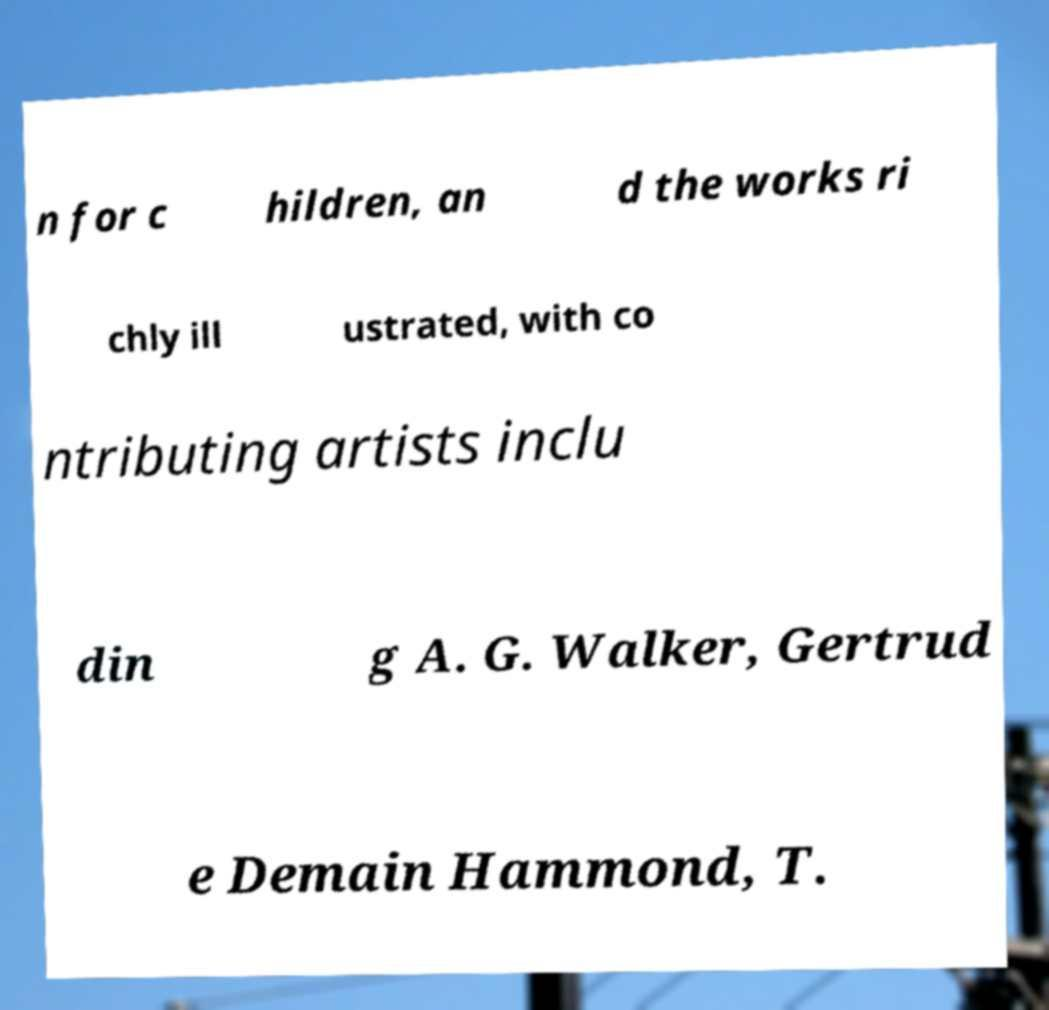Please read and relay the text visible in this image. What does it say? n for c hildren, an d the works ri chly ill ustrated, with co ntributing artists inclu din g A. G. Walker, Gertrud e Demain Hammond, T. 